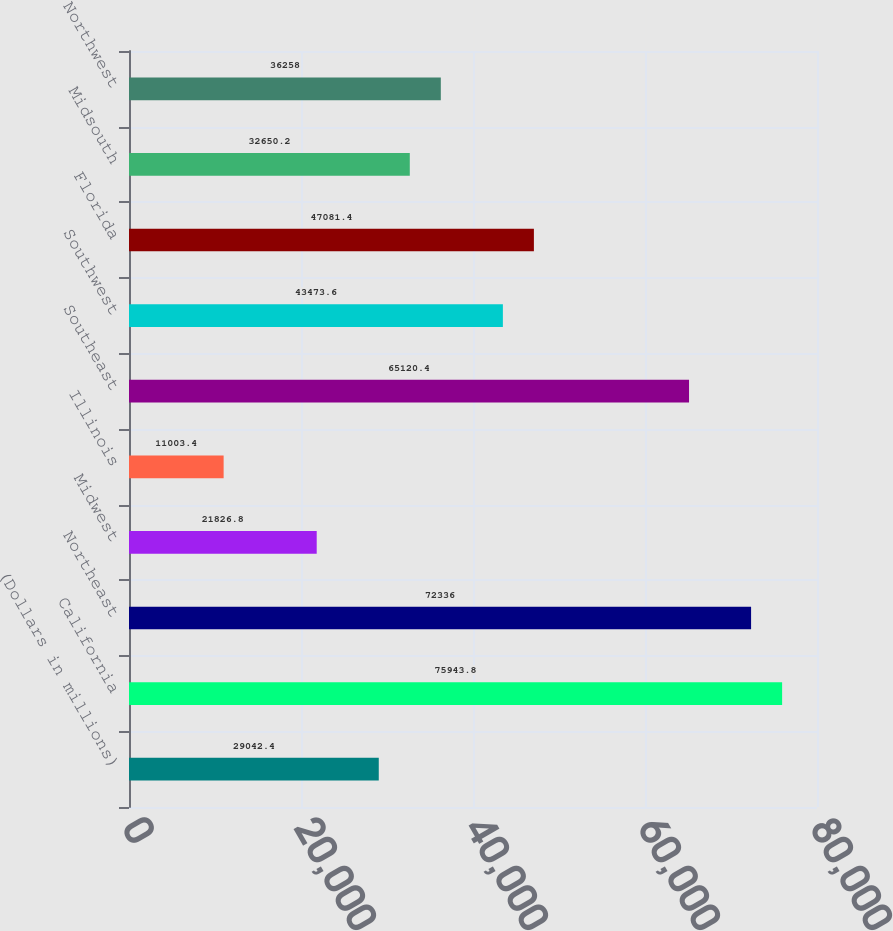Convert chart. <chart><loc_0><loc_0><loc_500><loc_500><bar_chart><fcel>(Dollars in millions)<fcel>California<fcel>Northeast<fcel>Midwest<fcel>Illinois<fcel>Southeast<fcel>Southwest<fcel>Florida<fcel>Midsouth<fcel>Northwest<nl><fcel>29042.4<fcel>75943.8<fcel>72336<fcel>21826.8<fcel>11003.4<fcel>65120.4<fcel>43473.6<fcel>47081.4<fcel>32650.2<fcel>36258<nl></chart> 